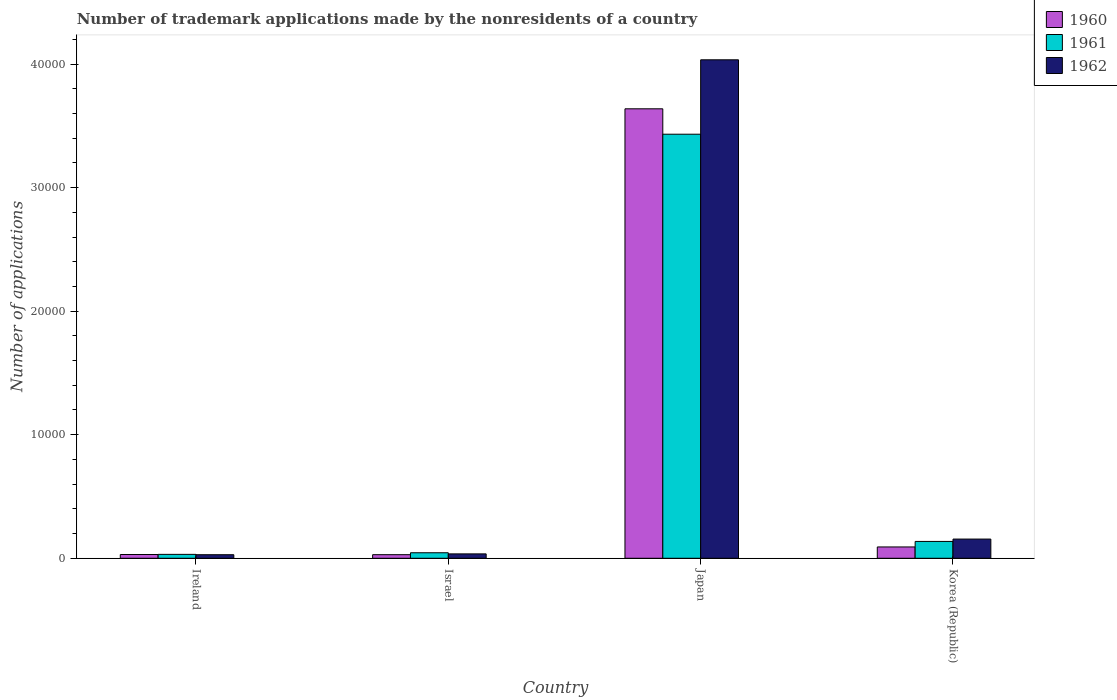Are the number of bars per tick equal to the number of legend labels?
Provide a succinct answer. Yes. Are the number of bars on each tick of the X-axis equal?
Your response must be concise. Yes. How many bars are there on the 1st tick from the right?
Keep it short and to the point. 3. What is the number of trademark applications made by the nonresidents in 1960 in Korea (Republic)?
Provide a short and direct response. 916. Across all countries, what is the maximum number of trademark applications made by the nonresidents in 1960?
Offer a terse response. 3.64e+04. Across all countries, what is the minimum number of trademark applications made by the nonresidents in 1961?
Ensure brevity in your answer.  316. In which country was the number of trademark applications made by the nonresidents in 1962 maximum?
Give a very brief answer. Japan. What is the total number of trademark applications made by the nonresidents in 1961 in the graph?
Ensure brevity in your answer.  3.64e+04. What is the difference between the number of trademark applications made by the nonresidents in 1961 in Ireland and that in Israel?
Provide a succinct answer. -130. What is the difference between the number of trademark applications made by the nonresidents in 1961 in Israel and the number of trademark applications made by the nonresidents in 1960 in Korea (Republic)?
Give a very brief answer. -470. What is the average number of trademark applications made by the nonresidents in 1961 per country?
Ensure brevity in your answer.  9111.25. What is the difference between the number of trademark applications made by the nonresidents of/in 1962 and number of trademark applications made by the nonresidents of/in 1961 in Japan?
Your answer should be very brief. 6023. What is the ratio of the number of trademark applications made by the nonresidents in 1960 in Japan to that in Korea (Republic)?
Your response must be concise. 39.71. What is the difference between the highest and the second highest number of trademark applications made by the nonresidents in 1962?
Your response must be concise. 1199. What is the difference between the highest and the lowest number of trademark applications made by the nonresidents in 1961?
Offer a very short reply. 3.40e+04. How many bars are there?
Your answer should be compact. 12. What is the difference between two consecutive major ticks on the Y-axis?
Keep it short and to the point. 10000. Are the values on the major ticks of Y-axis written in scientific E-notation?
Provide a short and direct response. No. Does the graph contain grids?
Provide a short and direct response. No. Where does the legend appear in the graph?
Your answer should be very brief. Top right. How many legend labels are there?
Give a very brief answer. 3. How are the legend labels stacked?
Give a very brief answer. Vertical. What is the title of the graph?
Offer a terse response. Number of trademark applications made by the nonresidents of a country. What is the label or title of the Y-axis?
Offer a very short reply. Number of applications. What is the Number of applications in 1960 in Ireland?
Provide a short and direct response. 305. What is the Number of applications of 1961 in Ireland?
Keep it short and to the point. 316. What is the Number of applications of 1962 in Ireland?
Offer a terse response. 288. What is the Number of applications of 1960 in Israel?
Provide a succinct answer. 290. What is the Number of applications of 1961 in Israel?
Provide a succinct answer. 446. What is the Number of applications of 1962 in Israel?
Your response must be concise. 355. What is the Number of applications in 1960 in Japan?
Keep it short and to the point. 3.64e+04. What is the Number of applications of 1961 in Japan?
Offer a terse response. 3.43e+04. What is the Number of applications of 1962 in Japan?
Provide a succinct answer. 4.03e+04. What is the Number of applications of 1960 in Korea (Republic)?
Offer a very short reply. 916. What is the Number of applications in 1961 in Korea (Republic)?
Offer a very short reply. 1363. What is the Number of applications of 1962 in Korea (Republic)?
Provide a succinct answer. 1554. Across all countries, what is the maximum Number of applications of 1960?
Your answer should be very brief. 3.64e+04. Across all countries, what is the maximum Number of applications in 1961?
Keep it short and to the point. 3.43e+04. Across all countries, what is the maximum Number of applications of 1962?
Provide a short and direct response. 4.03e+04. Across all countries, what is the minimum Number of applications in 1960?
Your answer should be compact. 290. Across all countries, what is the minimum Number of applications in 1961?
Ensure brevity in your answer.  316. Across all countries, what is the minimum Number of applications of 1962?
Offer a very short reply. 288. What is the total Number of applications of 1960 in the graph?
Provide a succinct answer. 3.79e+04. What is the total Number of applications in 1961 in the graph?
Your answer should be very brief. 3.64e+04. What is the total Number of applications in 1962 in the graph?
Give a very brief answer. 4.25e+04. What is the difference between the Number of applications of 1961 in Ireland and that in Israel?
Keep it short and to the point. -130. What is the difference between the Number of applications in 1962 in Ireland and that in Israel?
Your answer should be very brief. -67. What is the difference between the Number of applications in 1960 in Ireland and that in Japan?
Your answer should be compact. -3.61e+04. What is the difference between the Number of applications of 1961 in Ireland and that in Japan?
Give a very brief answer. -3.40e+04. What is the difference between the Number of applications of 1962 in Ireland and that in Japan?
Keep it short and to the point. -4.01e+04. What is the difference between the Number of applications in 1960 in Ireland and that in Korea (Republic)?
Your answer should be compact. -611. What is the difference between the Number of applications in 1961 in Ireland and that in Korea (Republic)?
Your answer should be very brief. -1047. What is the difference between the Number of applications in 1962 in Ireland and that in Korea (Republic)?
Offer a terse response. -1266. What is the difference between the Number of applications of 1960 in Israel and that in Japan?
Ensure brevity in your answer.  -3.61e+04. What is the difference between the Number of applications of 1961 in Israel and that in Japan?
Make the answer very short. -3.39e+04. What is the difference between the Number of applications of 1962 in Israel and that in Japan?
Your answer should be compact. -4.00e+04. What is the difference between the Number of applications in 1960 in Israel and that in Korea (Republic)?
Keep it short and to the point. -626. What is the difference between the Number of applications in 1961 in Israel and that in Korea (Republic)?
Give a very brief answer. -917. What is the difference between the Number of applications of 1962 in Israel and that in Korea (Republic)?
Ensure brevity in your answer.  -1199. What is the difference between the Number of applications of 1960 in Japan and that in Korea (Republic)?
Offer a very short reply. 3.55e+04. What is the difference between the Number of applications in 1961 in Japan and that in Korea (Republic)?
Offer a terse response. 3.30e+04. What is the difference between the Number of applications of 1962 in Japan and that in Korea (Republic)?
Make the answer very short. 3.88e+04. What is the difference between the Number of applications in 1960 in Ireland and the Number of applications in 1961 in Israel?
Your answer should be very brief. -141. What is the difference between the Number of applications in 1960 in Ireland and the Number of applications in 1962 in Israel?
Offer a terse response. -50. What is the difference between the Number of applications in 1961 in Ireland and the Number of applications in 1962 in Israel?
Make the answer very short. -39. What is the difference between the Number of applications in 1960 in Ireland and the Number of applications in 1961 in Japan?
Ensure brevity in your answer.  -3.40e+04. What is the difference between the Number of applications in 1960 in Ireland and the Number of applications in 1962 in Japan?
Make the answer very short. -4.00e+04. What is the difference between the Number of applications in 1961 in Ireland and the Number of applications in 1962 in Japan?
Your response must be concise. -4.00e+04. What is the difference between the Number of applications of 1960 in Ireland and the Number of applications of 1961 in Korea (Republic)?
Your answer should be compact. -1058. What is the difference between the Number of applications in 1960 in Ireland and the Number of applications in 1962 in Korea (Republic)?
Your answer should be compact. -1249. What is the difference between the Number of applications in 1961 in Ireland and the Number of applications in 1962 in Korea (Republic)?
Ensure brevity in your answer.  -1238. What is the difference between the Number of applications in 1960 in Israel and the Number of applications in 1961 in Japan?
Provide a short and direct response. -3.40e+04. What is the difference between the Number of applications of 1960 in Israel and the Number of applications of 1962 in Japan?
Provide a short and direct response. -4.01e+04. What is the difference between the Number of applications of 1961 in Israel and the Number of applications of 1962 in Japan?
Give a very brief answer. -3.99e+04. What is the difference between the Number of applications of 1960 in Israel and the Number of applications of 1961 in Korea (Republic)?
Offer a terse response. -1073. What is the difference between the Number of applications of 1960 in Israel and the Number of applications of 1962 in Korea (Republic)?
Your response must be concise. -1264. What is the difference between the Number of applications of 1961 in Israel and the Number of applications of 1962 in Korea (Republic)?
Your answer should be compact. -1108. What is the difference between the Number of applications of 1960 in Japan and the Number of applications of 1961 in Korea (Republic)?
Keep it short and to the point. 3.50e+04. What is the difference between the Number of applications in 1960 in Japan and the Number of applications in 1962 in Korea (Republic)?
Offer a terse response. 3.48e+04. What is the difference between the Number of applications of 1961 in Japan and the Number of applications of 1962 in Korea (Republic)?
Your answer should be very brief. 3.28e+04. What is the average Number of applications in 1960 per country?
Provide a short and direct response. 9472. What is the average Number of applications in 1961 per country?
Ensure brevity in your answer.  9111.25. What is the average Number of applications in 1962 per country?
Your response must be concise. 1.06e+04. What is the difference between the Number of applications of 1960 and Number of applications of 1962 in Ireland?
Provide a succinct answer. 17. What is the difference between the Number of applications of 1961 and Number of applications of 1962 in Ireland?
Give a very brief answer. 28. What is the difference between the Number of applications of 1960 and Number of applications of 1961 in Israel?
Offer a terse response. -156. What is the difference between the Number of applications of 1960 and Number of applications of 1962 in Israel?
Give a very brief answer. -65. What is the difference between the Number of applications in 1961 and Number of applications in 1962 in Israel?
Your answer should be very brief. 91. What is the difference between the Number of applications in 1960 and Number of applications in 1961 in Japan?
Provide a short and direct response. 2057. What is the difference between the Number of applications of 1960 and Number of applications of 1962 in Japan?
Ensure brevity in your answer.  -3966. What is the difference between the Number of applications in 1961 and Number of applications in 1962 in Japan?
Give a very brief answer. -6023. What is the difference between the Number of applications in 1960 and Number of applications in 1961 in Korea (Republic)?
Ensure brevity in your answer.  -447. What is the difference between the Number of applications in 1960 and Number of applications in 1962 in Korea (Republic)?
Ensure brevity in your answer.  -638. What is the difference between the Number of applications in 1961 and Number of applications in 1962 in Korea (Republic)?
Ensure brevity in your answer.  -191. What is the ratio of the Number of applications in 1960 in Ireland to that in Israel?
Provide a succinct answer. 1.05. What is the ratio of the Number of applications in 1961 in Ireland to that in Israel?
Your answer should be compact. 0.71. What is the ratio of the Number of applications of 1962 in Ireland to that in Israel?
Your answer should be compact. 0.81. What is the ratio of the Number of applications of 1960 in Ireland to that in Japan?
Offer a terse response. 0.01. What is the ratio of the Number of applications of 1961 in Ireland to that in Japan?
Provide a short and direct response. 0.01. What is the ratio of the Number of applications of 1962 in Ireland to that in Japan?
Keep it short and to the point. 0.01. What is the ratio of the Number of applications in 1960 in Ireland to that in Korea (Republic)?
Offer a terse response. 0.33. What is the ratio of the Number of applications of 1961 in Ireland to that in Korea (Republic)?
Make the answer very short. 0.23. What is the ratio of the Number of applications of 1962 in Ireland to that in Korea (Republic)?
Provide a succinct answer. 0.19. What is the ratio of the Number of applications in 1960 in Israel to that in Japan?
Keep it short and to the point. 0.01. What is the ratio of the Number of applications of 1961 in Israel to that in Japan?
Your answer should be very brief. 0.01. What is the ratio of the Number of applications in 1962 in Israel to that in Japan?
Provide a succinct answer. 0.01. What is the ratio of the Number of applications in 1960 in Israel to that in Korea (Republic)?
Provide a short and direct response. 0.32. What is the ratio of the Number of applications of 1961 in Israel to that in Korea (Republic)?
Your response must be concise. 0.33. What is the ratio of the Number of applications of 1962 in Israel to that in Korea (Republic)?
Your answer should be compact. 0.23. What is the ratio of the Number of applications in 1960 in Japan to that in Korea (Republic)?
Provide a succinct answer. 39.71. What is the ratio of the Number of applications in 1961 in Japan to that in Korea (Republic)?
Keep it short and to the point. 25.18. What is the ratio of the Number of applications in 1962 in Japan to that in Korea (Republic)?
Provide a succinct answer. 25.96. What is the difference between the highest and the second highest Number of applications of 1960?
Offer a very short reply. 3.55e+04. What is the difference between the highest and the second highest Number of applications in 1961?
Offer a terse response. 3.30e+04. What is the difference between the highest and the second highest Number of applications in 1962?
Offer a terse response. 3.88e+04. What is the difference between the highest and the lowest Number of applications in 1960?
Provide a short and direct response. 3.61e+04. What is the difference between the highest and the lowest Number of applications of 1961?
Your answer should be very brief. 3.40e+04. What is the difference between the highest and the lowest Number of applications in 1962?
Provide a succinct answer. 4.01e+04. 